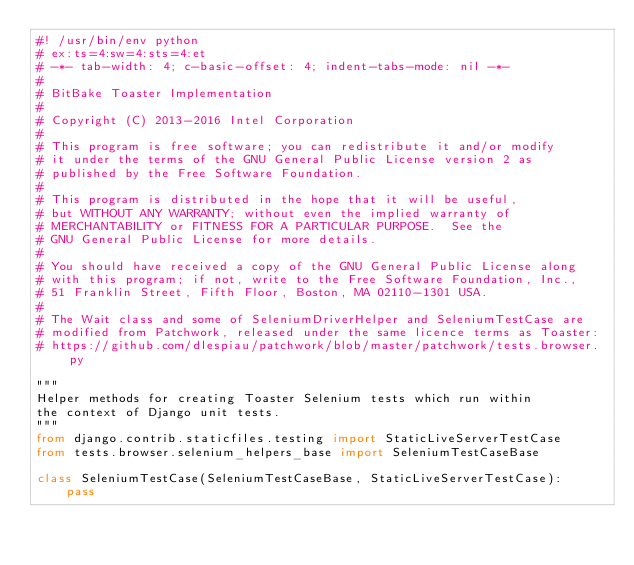<code> <loc_0><loc_0><loc_500><loc_500><_Python_>#! /usr/bin/env python
# ex:ts=4:sw=4:sts=4:et
# -*- tab-width: 4; c-basic-offset: 4; indent-tabs-mode: nil -*-
#
# BitBake Toaster Implementation
#
# Copyright (C) 2013-2016 Intel Corporation
#
# This program is free software; you can redistribute it and/or modify
# it under the terms of the GNU General Public License version 2 as
# published by the Free Software Foundation.
#
# This program is distributed in the hope that it will be useful,
# but WITHOUT ANY WARRANTY; without even the implied warranty of
# MERCHANTABILITY or FITNESS FOR A PARTICULAR PURPOSE.  See the
# GNU General Public License for more details.
#
# You should have received a copy of the GNU General Public License along
# with this program; if not, write to the Free Software Foundation, Inc.,
# 51 Franklin Street, Fifth Floor, Boston, MA 02110-1301 USA.
#
# The Wait class and some of SeleniumDriverHelper and SeleniumTestCase are
# modified from Patchwork, released under the same licence terms as Toaster:
# https://github.com/dlespiau/patchwork/blob/master/patchwork/tests.browser.py

"""
Helper methods for creating Toaster Selenium tests which run within
the context of Django unit tests.
"""
from django.contrib.staticfiles.testing import StaticLiveServerTestCase
from tests.browser.selenium_helpers_base import SeleniumTestCaseBase

class SeleniumTestCase(SeleniumTestCaseBase, StaticLiveServerTestCase):
    pass
</code> 